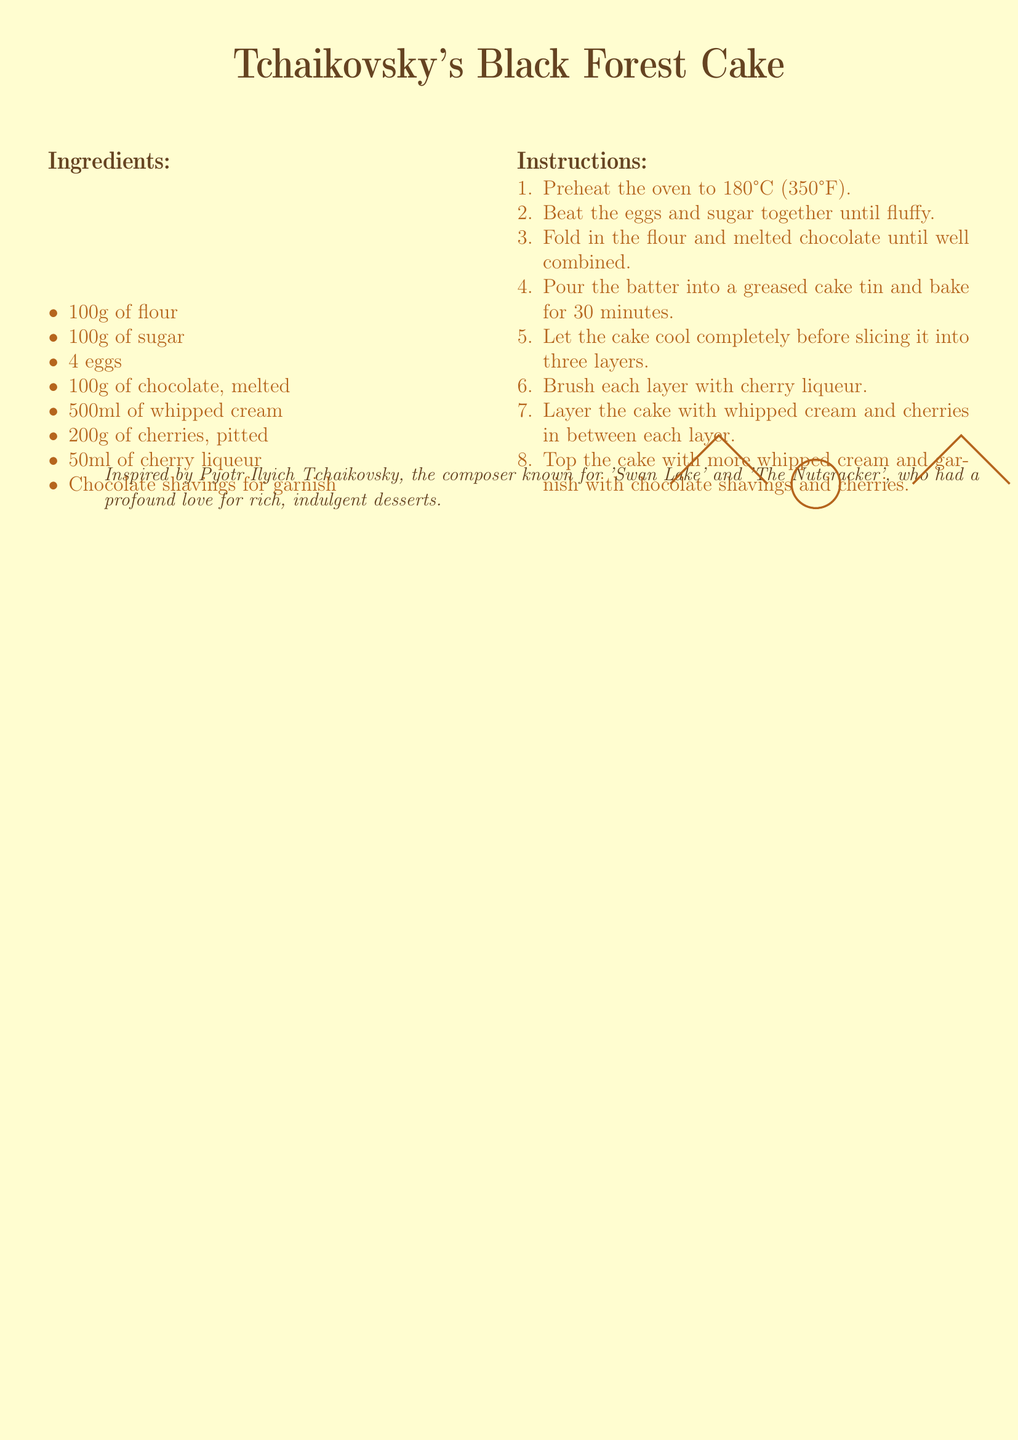What is the name of the dessert? The dessert mentioned in the document is titled prominently at the top, which is Tchaikovsky's Black Forest Cake.
Answer: Tchaikovsky's Black Forest Cake How many eggs are needed? The ingredients list specifies the quantity of eggs required for the recipe, which is 4.
Answer: 4 What temperature should the oven be preheated to? The instructions provide the specific temperature for preheating the oven, which is 180°C (350°F).
Answer: 180°C (350°F) Who is the dessert inspired by? The text at the bottom of the document mentions the composer that the dessert is inspired by, which is Pyotr Ilyich Tchaikovsky.
Answer: Pyotr Ilyich Tchaikovsky How many layers should the cake be sliced into? The instructions explicitly state that the cake should be sliced into three layers.
Answer: three What ingredient is used for brushing the cake layers? The instructions include a specific ingredient that is brushed onto the layers after baking, which is cherry liqueur.
Answer: cherry liqueur How much whipped cream is listed in the ingredients? The ingredients clearly list the quantity of whipped cream used, which is 500ml.
Answer: 500ml What fruit is included in the recipe? The ingredient list mentions a specific fruit that is included, which is cherries.
Answer: cherries 